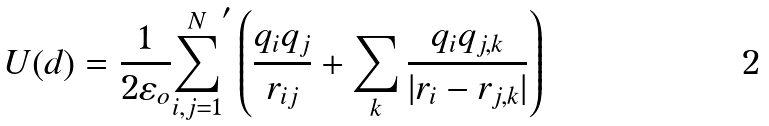<formula> <loc_0><loc_0><loc_500><loc_500>U ( d ) = \frac { 1 } { 2 \varepsilon _ { o } } { \sum _ { i , j = 1 } ^ { N } } ^ { \prime } \left ( \frac { q _ { i } q _ { j } } { r _ { i j } } + \sum _ { k } \frac { q _ { i } q _ { j , k } } { | r _ { i } - r _ { j , k } | } \right )</formula> 